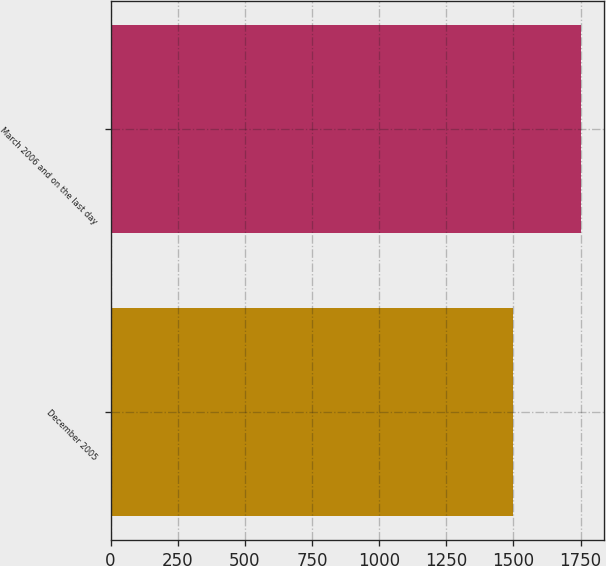Convert chart. <chart><loc_0><loc_0><loc_500><loc_500><bar_chart><fcel>December 2005<fcel>March 2006 and on the last day<nl><fcel>1500<fcel>1750<nl></chart> 